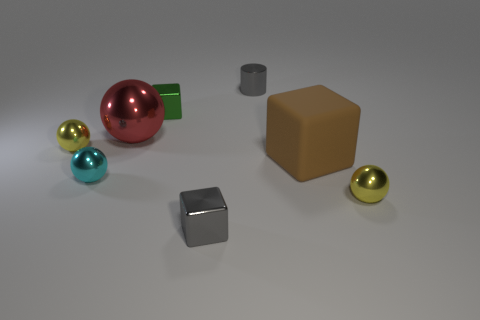Is there any other thing that has the same material as the brown cube?
Provide a short and direct response. No. How many other things are there of the same material as the large ball?
Provide a short and direct response. 6. What shape is the small yellow object on the left side of the gray metal object that is behind the cyan metal thing?
Provide a succinct answer. Sphere. There is a yellow sphere behind the large matte cube; how big is it?
Offer a terse response. Small. Are the big red object and the small green object made of the same material?
Your response must be concise. Yes. There is a tiny green object that is made of the same material as the cyan thing; what is its shape?
Offer a very short reply. Cube. Is there anything else that has the same color as the cylinder?
Your response must be concise. Yes. There is a small cube that is behind the brown object; what is its color?
Keep it short and to the point. Green. Does the shiny sphere that is on the right side of the gray cylinder have the same color as the big metallic object?
Offer a terse response. No. There is another large thing that is the same shape as the cyan metallic thing; what material is it?
Ensure brevity in your answer.  Metal. 